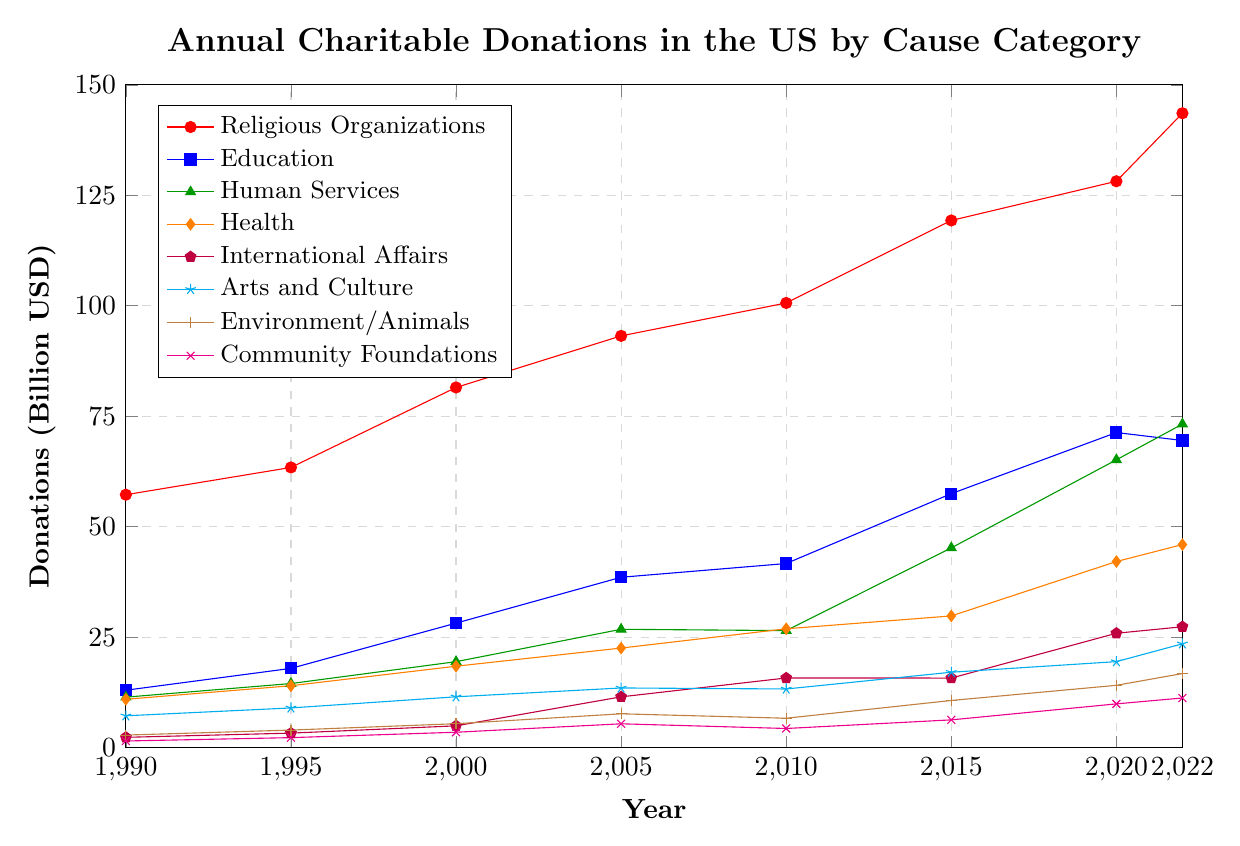Which cause category received the highest donations in 2022? Look at the data line for 2022 and identify which category has the highest value. The highest value in 2022 is 143.56 billion USD, which corresponds to Religious Organizations.
Answer: Religious Organizations How did donations to Education change from 1990 to 2022? Review the values for Education for 1990 and 2022 and calculate the difference. In 1990, the donation was 13.00 billion USD and in 2022, it was 69.51 billion USD. The change is 69.51 - 13.00 = 56.51 billion USD increase.
Answer: Increased by 56.51 billion USD Which category showed the most significant growth in donations between 1990 and 2022? Calculate the difference in donations from 1990 to 2022 for each category and compare the values. Religious Organizations increased by 143.56 - 57.24 = 86.32 billion USD, Education by 69.51 - 13.00 = 56.51 billion USD, Human Services by 73.22 - 11.43 = 61.79 billion USD, Health by 45.96 - 10.95 = 35.01 billion USD, International Affairs by 27.36 - 2.34 = 25.02 billion USD, Arts and Culture by 23.50 - 7.21 = 16.29 billion USD, Environment/Animals by 16.77 - 2.85 = 13.92 billion USD, and Community Foundations by 11.24 - 1.51 = 9.73 billion USD. The category with the highest growth is Religious Organizations with 86.32 billion USD increase.
Answer: Religious Organizations In which year did donations to Health first surpass 20 billion USD? Follow the trend line for Health and find the first data point where donations exceed 20 billion USD. In 2005, donations were 22.54 billion USD.
Answer: 2005 Compare the donation growth between Environment/Animals and Community Foundations from 1990 to 2022. Which had a higher growth rate? Calculate the growth for both categories from 1990 to 2022. Environment/Animals grew from 2.85 to 16.77 billion USD, an increase of 16.77 - 2.85 = 13.92 billion USD. Community Foundations grew from 1.51 to 11.24 billion USD, an increase of 11.24 - 1.51 = 9.73 billion USD. Compare the two growth values; 13.92 billion USD (Environment/Animals) is higher than 9.73 billion USD (Community Foundations).
Answer: Environment/Animals How many categories had donations exceeding 50 billion USD in 2020? Examine the data points for 2020 and count the categories where the donation values exceed 50 billion USD. Human Services (65.14 billion USD) and Education (71.31 billion USD) are the two categories with donations exceeding 50 billion USD.
Answer: 2 What was the total amount donated across all categories in 2010? Add the values of all categories for the year 2010. Total = 100.63 (Religious Organizations) + 41.67 (Education) + 26.49 (Human Services) + 26.90 (Health) + 15.77 (International Affairs) + 13.28 (Arts and Culture) + 6.66 (Environment/Animals) + 4.34 (Community Foundations) = 235.74 billion USD
Answer: 235.74 billion USD By how much did the donations to International Affairs increase from 2000 to 2005? Find the difference in values for International Affairs between 2000 and 2005. In 2000 the donation was 4.94 billion USD, and in 2005 it was 11.50 billion USD. The increase is 11.50 - 4.94 = 6.56 billion USD.
Answer: 6.56 billion USD Which category had the least amount donated in 1990? Look at the donation values for 1990 and identify the smallest value. Community Foundations had 1.51 billion USD, which is the smallest value among all categories in 1990.
Answer: Community Foundations 